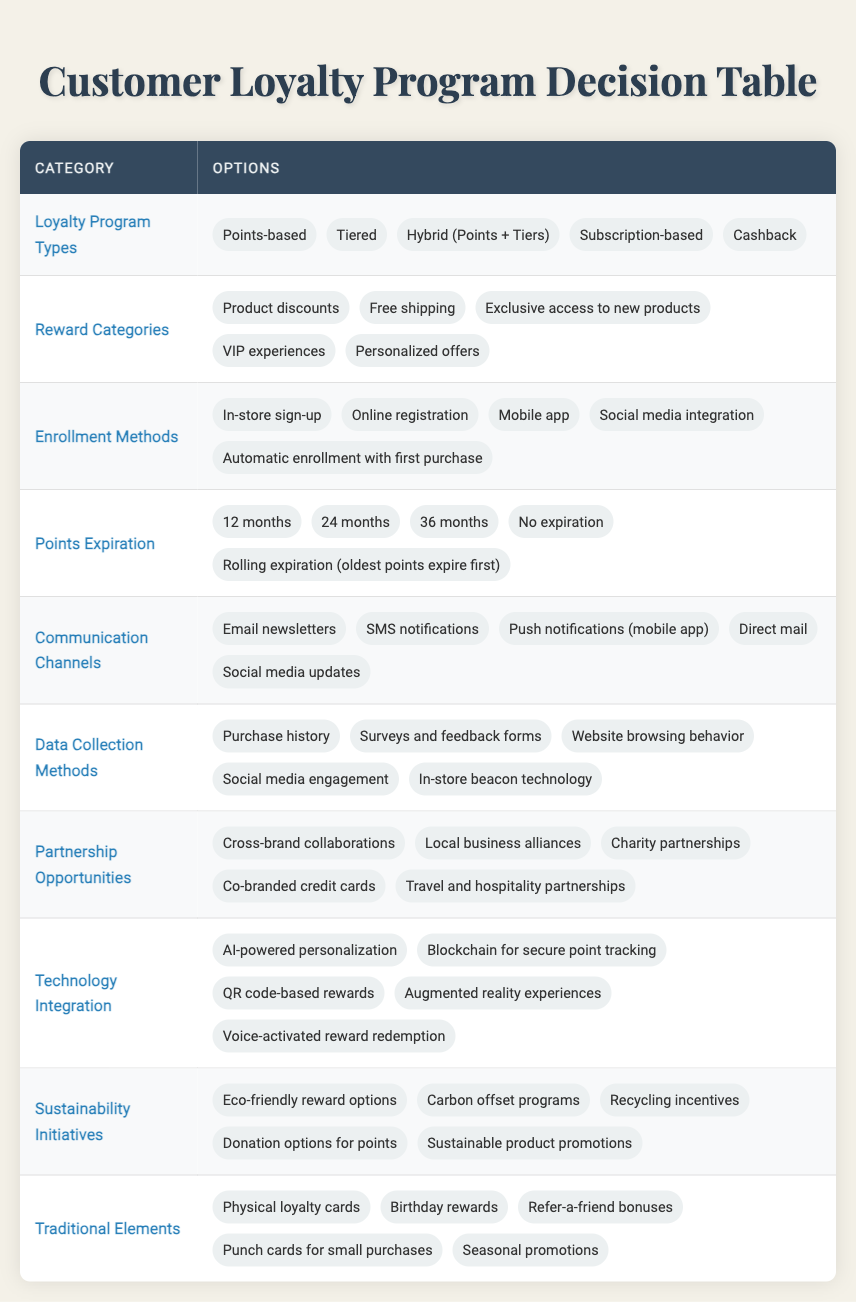What are the different types of loyalty programs listed? The table specifies five types of loyalty programs under the "Loyalty Program Types" category: Points-based, Tiered, Hybrid (Points + Tiers), Subscription-based, and Cashback. This information can be directly retrieved from that row in the table.
Answer: Points-based, Tiered, Hybrid (Points + Tiers), Subscription-based, Cashback How many reward categories are available? In the "Reward Categories" section, five options are listed: Product discounts, Free shipping, Exclusive access to new products, VIP experiences, and Personalized offers. Therefore, counting these entries shows that there are five reward categories available.
Answer: 5 Is there an option for enrollment via social media integration? Yes, the "Enrollment Methods" section explicitly lists "Social media integration" as one of the options. This can be confirmed directly by looking at that row in the table.
Answer: Yes What is the maximum points expiration period listed? The table under "Points Expiration" includes several periods: 12 months, 24 months, 36 months, No expiration, and Rolling expiration. The maximum period from these options is 36 months. This can be identified easily by comparing the entries in that section.
Answer: 36 months Do all loyalty program types offer exclusive access to new products as a reward? No, exclusive access to new products is one of the reward categories, but it is not tied to every loyalty program type. It is necessary to check the "Reward Categories" independently of the program types, confirming that not all types will necessarily include this specific reward.
Answer: No Considering the enrollment methods, which one involves automatic action? Among the "Enrollment Methods," the option "Automatic enrollment with first purchase" indicates an automatic action. By identifying this specific phrase within the table, it shows this method does not require any active steps from the customer.
Answer: Automatic enrollment with first purchase If we consider the traditional elements, how many of these methods include physical items? The "Traditional Elements" section lists five options: Physical loyalty cards, Birthday rewards, Refer-a-friend bonuses, Punch cards for small purchases, and Seasonal promotions. Among these, Physical loyalty cards and Punch cards specifically involve physical items. Thus, two options include physical items.
Answer: 2 What is the only initiative under sustainability initiatives that allows for donations? The "Sustainability Initiatives" section includes various options, and "Donation options for points" specifically allows for donation, as evident from that row. This means that this particular option is the only one that mentions donations.
Answer: Donation options for points 